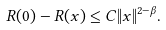<formula> <loc_0><loc_0><loc_500><loc_500>R ( 0 ) - R ( x ) \leq C \| x \| ^ { 2 - \beta } .</formula> 